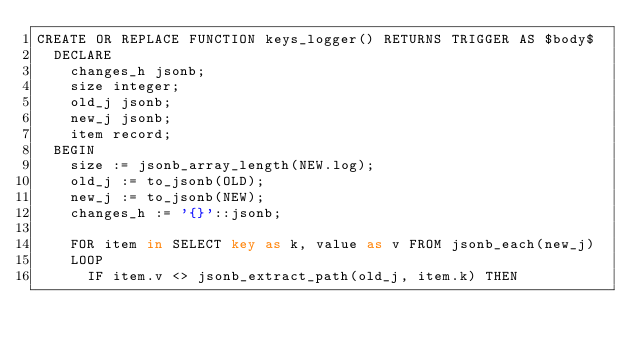<code> <loc_0><loc_0><loc_500><loc_500><_SQL_>CREATE OR REPLACE FUNCTION keys_logger() RETURNS TRIGGER AS $body$
  DECLARE
    changes_h jsonb;
    size integer;
    old_j jsonb;
    new_j jsonb;
    item record;
  BEGIN
    size := jsonb_array_length(NEW.log);
    old_j := to_jsonb(OLD);
    new_j := to_jsonb(NEW);
    changes_h := '{}'::jsonb;

    FOR item in SELECT key as k, value as v FROM jsonb_each(new_j)
    LOOP
      IF item.v <> jsonb_extract_path(old_j, item.k) THEN</code> 